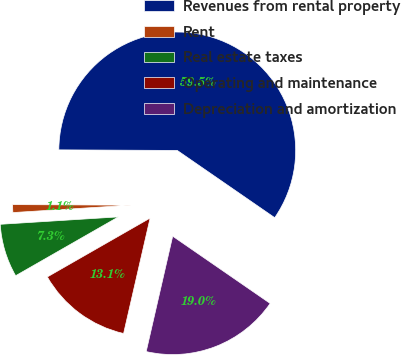Convert chart. <chart><loc_0><loc_0><loc_500><loc_500><pie_chart><fcel>Revenues from rental property<fcel>Rent<fcel>Real estate taxes<fcel>Operating and maintenance<fcel>Depreciation and amortization<nl><fcel>59.54%<fcel>1.07%<fcel>7.28%<fcel>13.13%<fcel>18.98%<nl></chart> 